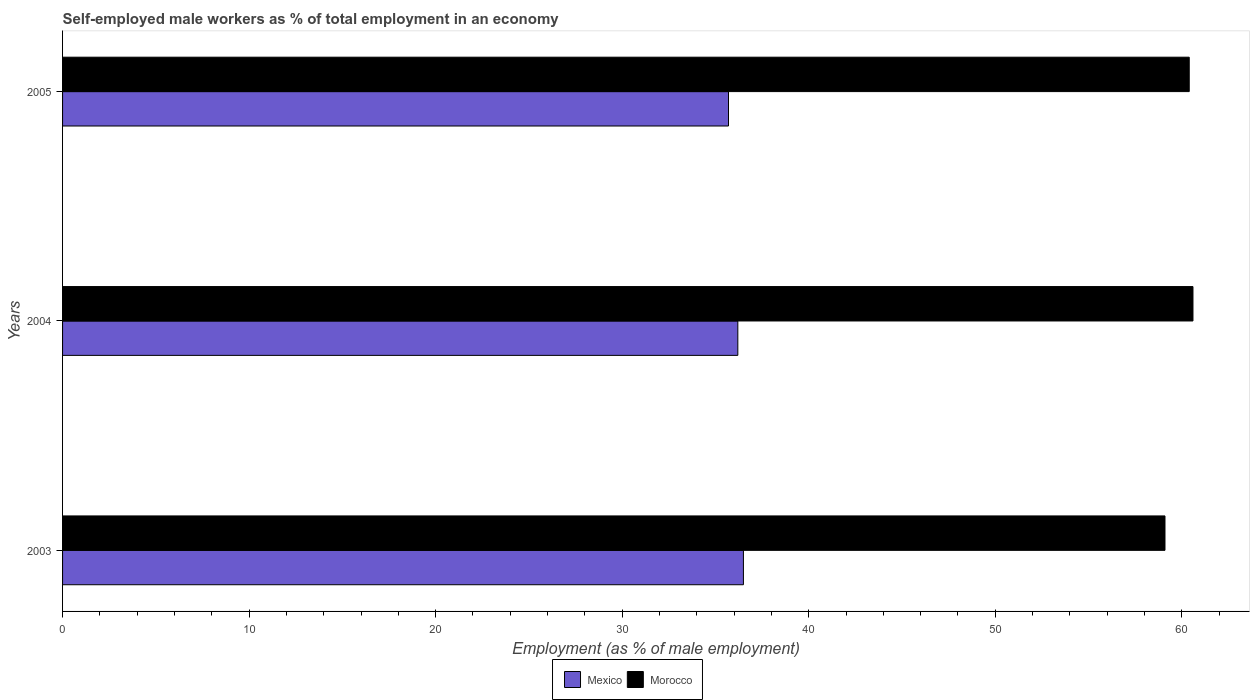How many different coloured bars are there?
Provide a short and direct response. 2. How many groups of bars are there?
Keep it short and to the point. 3. How many bars are there on the 2nd tick from the top?
Keep it short and to the point. 2. What is the label of the 3rd group of bars from the top?
Offer a very short reply. 2003. What is the percentage of self-employed male workers in Morocco in 2005?
Make the answer very short. 60.4. Across all years, what is the maximum percentage of self-employed male workers in Mexico?
Ensure brevity in your answer.  36.5. Across all years, what is the minimum percentage of self-employed male workers in Mexico?
Your answer should be compact. 35.7. What is the total percentage of self-employed male workers in Morocco in the graph?
Your answer should be compact. 180.1. What is the difference between the percentage of self-employed male workers in Mexico in 2003 and that in 2004?
Offer a terse response. 0.3. What is the difference between the percentage of self-employed male workers in Mexico in 2004 and the percentage of self-employed male workers in Morocco in 2005?
Keep it short and to the point. -24.2. What is the average percentage of self-employed male workers in Morocco per year?
Keep it short and to the point. 60.03. In the year 2005, what is the difference between the percentage of self-employed male workers in Mexico and percentage of self-employed male workers in Morocco?
Your answer should be very brief. -24.7. In how many years, is the percentage of self-employed male workers in Morocco greater than 48 %?
Keep it short and to the point. 3. What is the ratio of the percentage of self-employed male workers in Morocco in 2004 to that in 2005?
Provide a short and direct response. 1. Is the percentage of self-employed male workers in Morocco in 2004 less than that in 2005?
Give a very brief answer. No. Is the difference between the percentage of self-employed male workers in Mexico in 2003 and 2005 greater than the difference between the percentage of self-employed male workers in Morocco in 2003 and 2005?
Provide a succinct answer. Yes. What is the difference between the highest and the second highest percentage of self-employed male workers in Morocco?
Your answer should be very brief. 0.2. What is the difference between the highest and the lowest percentage of self-employed male workers in Mexico?
Make the answer very short. 0.8. What does the 1st bar from the top in 2004 represents?
Give a very brief answer. Morocco. What is the difference between two consecutive major ticks on the X-axis?
Give a very brief answer. 10. Does the graph contain any zero values?
Your answer should be very brief. No. Does the graph contain grids?
Your answer should be very brief. No. Where does the legend appear in the graph?
Make the answer very short. Bottom center. How many legend labels are there?
Keep it short and to the point. 2. What is the title of the graph?
Ensure brevity in your answer.  Self-employed male workers as % of total employment in an economy. Does "Least developed countries" appear as one of the legend labels in the graph?
Provide a short and direct response. No. What is the label or title of the X-axis?
Keep it short and to the point. Employment (as % of male employment). What is the label or title of the Y-axis?
Offer a terse response. Years. What is the Employment (as % of male employment) of Mexico in 2003?
Provide a succinct answer. 36.5. What is the Employment (as % of male employment) of Morocco in 2003?
Offer a very short reply. 59.1. What is the Employment (as % of male employment) in Mexico in 2004?
Provide a succinct answer. 36.2. What is the Employment (as % of male employment) of Morocco in 2004?
Offer a very short reply. 60.6. What is the Employment (as % of male employment) in Mexico in 2005?
Your answer should be very brief. 35.7. What is the Employment (as % of male employment) in Morocco in 2005?
Keep it short and to the point. 60.4. Across all years, what is the maximum Employment (as % of male employment) in Mexico?
Keep it short and to the point. 36.5. Across all years, what is the maximum Employment (as % of male employment) in Morocco?
Ensure brevity in your answer.  60.6. Across all years, what is the minimum Employment (as % of male employment) of Mexico?
Your response must be concise. 35.7. Across all years, what is the minimum Employment (as % of male employment) of Morocco?
Give a very brief answer. 59.1. What is the total Employment (as % of male employment) in Mexico in the graph?
Offer a terse response. 108.4. What is the total Employment (as % of male employment) in Morocco in the graph?
Give a very brief answer. 180.1. What is the difference between the Employment (as % of male employment) of Mexico in 2003 and that in 2004?
Ensure brevity in your answer.  0.3. What is the difference between the Employment (as % of male employment) of Mexico in 2003 and that in 2005?
Offer a very short reply. 0.8. What is the difference between the Employment (as % of male employment) in Mexico in 2004 and that in 2005?
Give a very brief answer. 0.5. What is the difference between the Employment (as % of male employment) in Morocco in 2004 and that in 2005?
Give a very brief answer. 0.2. What is the difference between the Employment (as % of male employment) in Mexico in 2003 and the Employment (as % of male employment) in Morocco in 2004?
Ensure brevity in your answer.  -24.1. What is the difference between the Employment (as % of male employment) in Mexico in 2003 and the Employment (as % of male employment) in Morocco in 2005?
Provide a succinct answer. -23.9. What is the difference between the Employment (as % of male employment) of Mexico in 2004 and the Employment (as % of male employment) of Morocco in 2005?
Your response must be concise. -24.2. What is the average Employment (as % of male employment) in Mexico per year?
Ensure brevity in your answer.  36.13. What is the average Employment (as % of male employment) in Morocco per year?
Ensure brevity in your answer.  60.03. In the year 2003, what is the difference between the Employment (as % of male employment) in Mexico and Employment (as % of male employment) in Morocco?
Give a very brief answer. -22.6. In the year 2004, what is the difference between the Employment (as % of male employment) of Mexico and Employment (as % of male employment) of Morocco?
Offer a terse response. -24.4. In the year 2005, what is the difference between the Employment (as % of male employment) of Mexico and Employment (as % of male employment) of Morocco?
Offer a very short reply. -24.7. What is the ratio of the Employment (as % of male employment) in Mexico in 2003 to that in 2004?
Make the answer very short. 1.01. What is the ratio of the Employment (as % of male employment) of Morocco in 2003 to that in 2004?
Your answer should be compact. 0.98. What is the ratio of the Employment (as % of male employment) of Mexico in 2003 to that in 2005?
Provide a succinct answer. 1.02. What is the ratio of the Employment (as % of male employment) in Morocco in 2003 to that in 2005?
Offer a terse response. 0.98. What is the difference between the highest and the lowest Employment (as % of male employment) in Morocco?
Your answer should be compact. 1.5. 